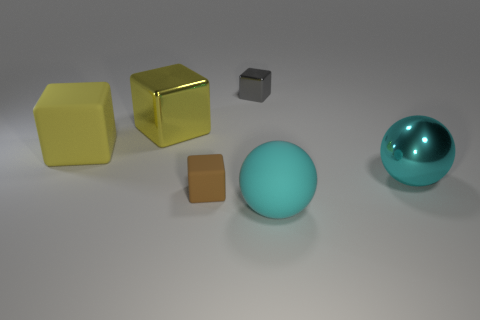Is there a metallic thing of the same size as the brown block?
Offer a very short reply. Yes. Are there an equal number of gray objects in front of the large metal ball and shiny things to the right of the yellow matte block?
Keep it short and to the point. No. Is the number of big cyan balls greater than the number of shiny things?
Ensure brevity in your answer.  No. How many metallic things are big objects or gray blocks?
Give a very brief answer. 3. How many tiny objects are the same color as the big matte cube?
Your response must be concise. 0. There is a cyan sphere right of the large cyan sphere that is in front of the small cube in front of the gray metal object; what is it made of?
Provide a succinct answer. Metal. There is a large block that is behind the rubber object that is left of the brown rubber thing; what is its color?
Ensure brevity in your answer.  Yellow. How many big objects are yellow blocks or gray metallic things?
Ensure brevity in your answer.  2. How many small brown cubes have the same material as the gray block?
Your answer should be compact. 0. There is a brown thing in front of the tiny gray cube; what is its size?
Provide a succinct answer. Small. 